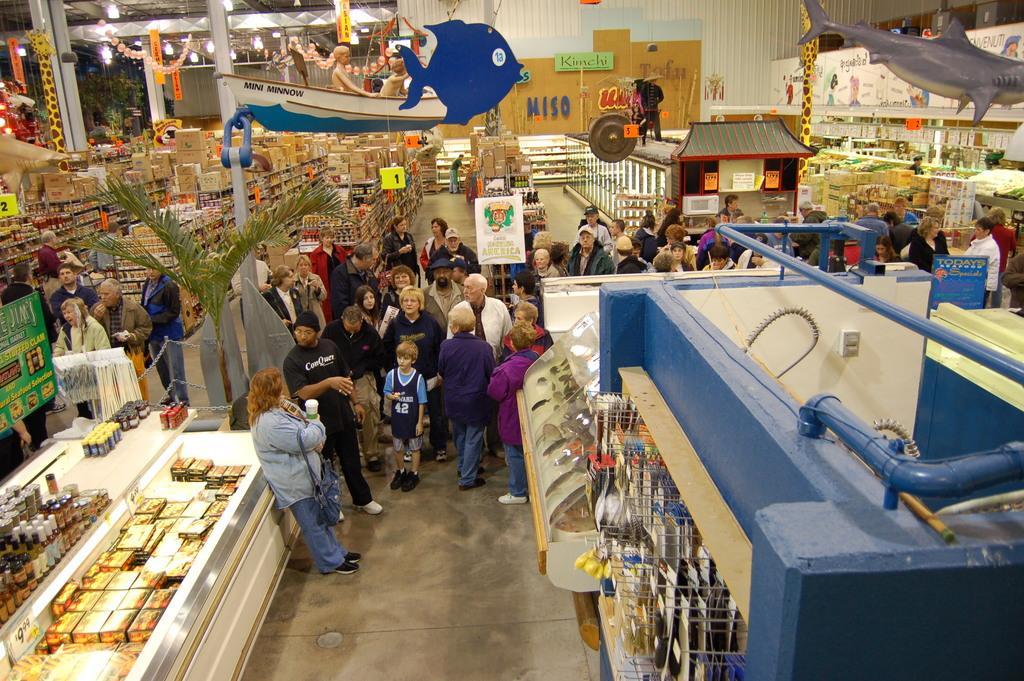In one or two sentences, can you explain what this image depicts? In this image we can see a group of people standing on the floor. We can also see some objects placed in the racks, some objects on the tables, a group of cardboard boxes placed one on the other, some boards with text on them, some balloons, ribbons, a plant, some ceiling lights and decors to a roof. On the right side we can see some metal poles. 